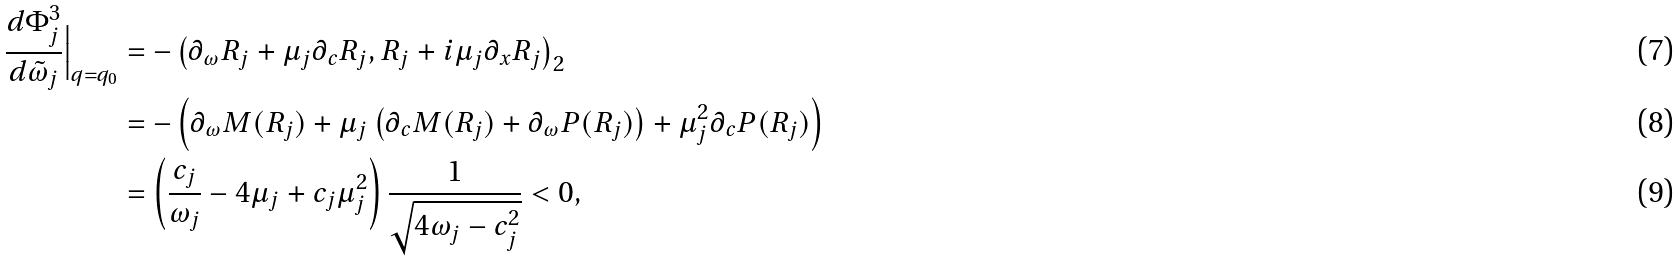<formula> <loc_0><loc_0><loc_500><loc_500>\frac { d \Phi _ { j } ^ { 3 } } { d \tilde { \omega } _ { j } } \Big | _ { q = q _ { 0 } } & = - \left ( \partial _ { \omega } R _ { j } + \mu _ { j } \partial _ { c } R _ { j } , R _ { j } + i \mu _ { j } \partial _ { x } R _ { j } \right ) _ { 2 } \\ & = - \left ( \partial _ { \omega } M ( R _ { j } ) + \mu _ { j } \left ( \partial _ { c } M ( R _ { j } ) + \partial _ { \omega } P ( R _ { j } ) \right ) + \mu _ { j } ^ { 2 } \partial _ { c } P ( R _ { j } ) \right ) \\ & = \left ( \frac { c _ { j } } { \omega _ { j } } - 4 \mu _ { j } + c _ { j } \mu _ { j } ^ { 2 } \right ) \frac { 1 } { \sqrt { 4 \omega _ { j } - c _ { j } ^ { 2 } } } < 0 ,</formula> 